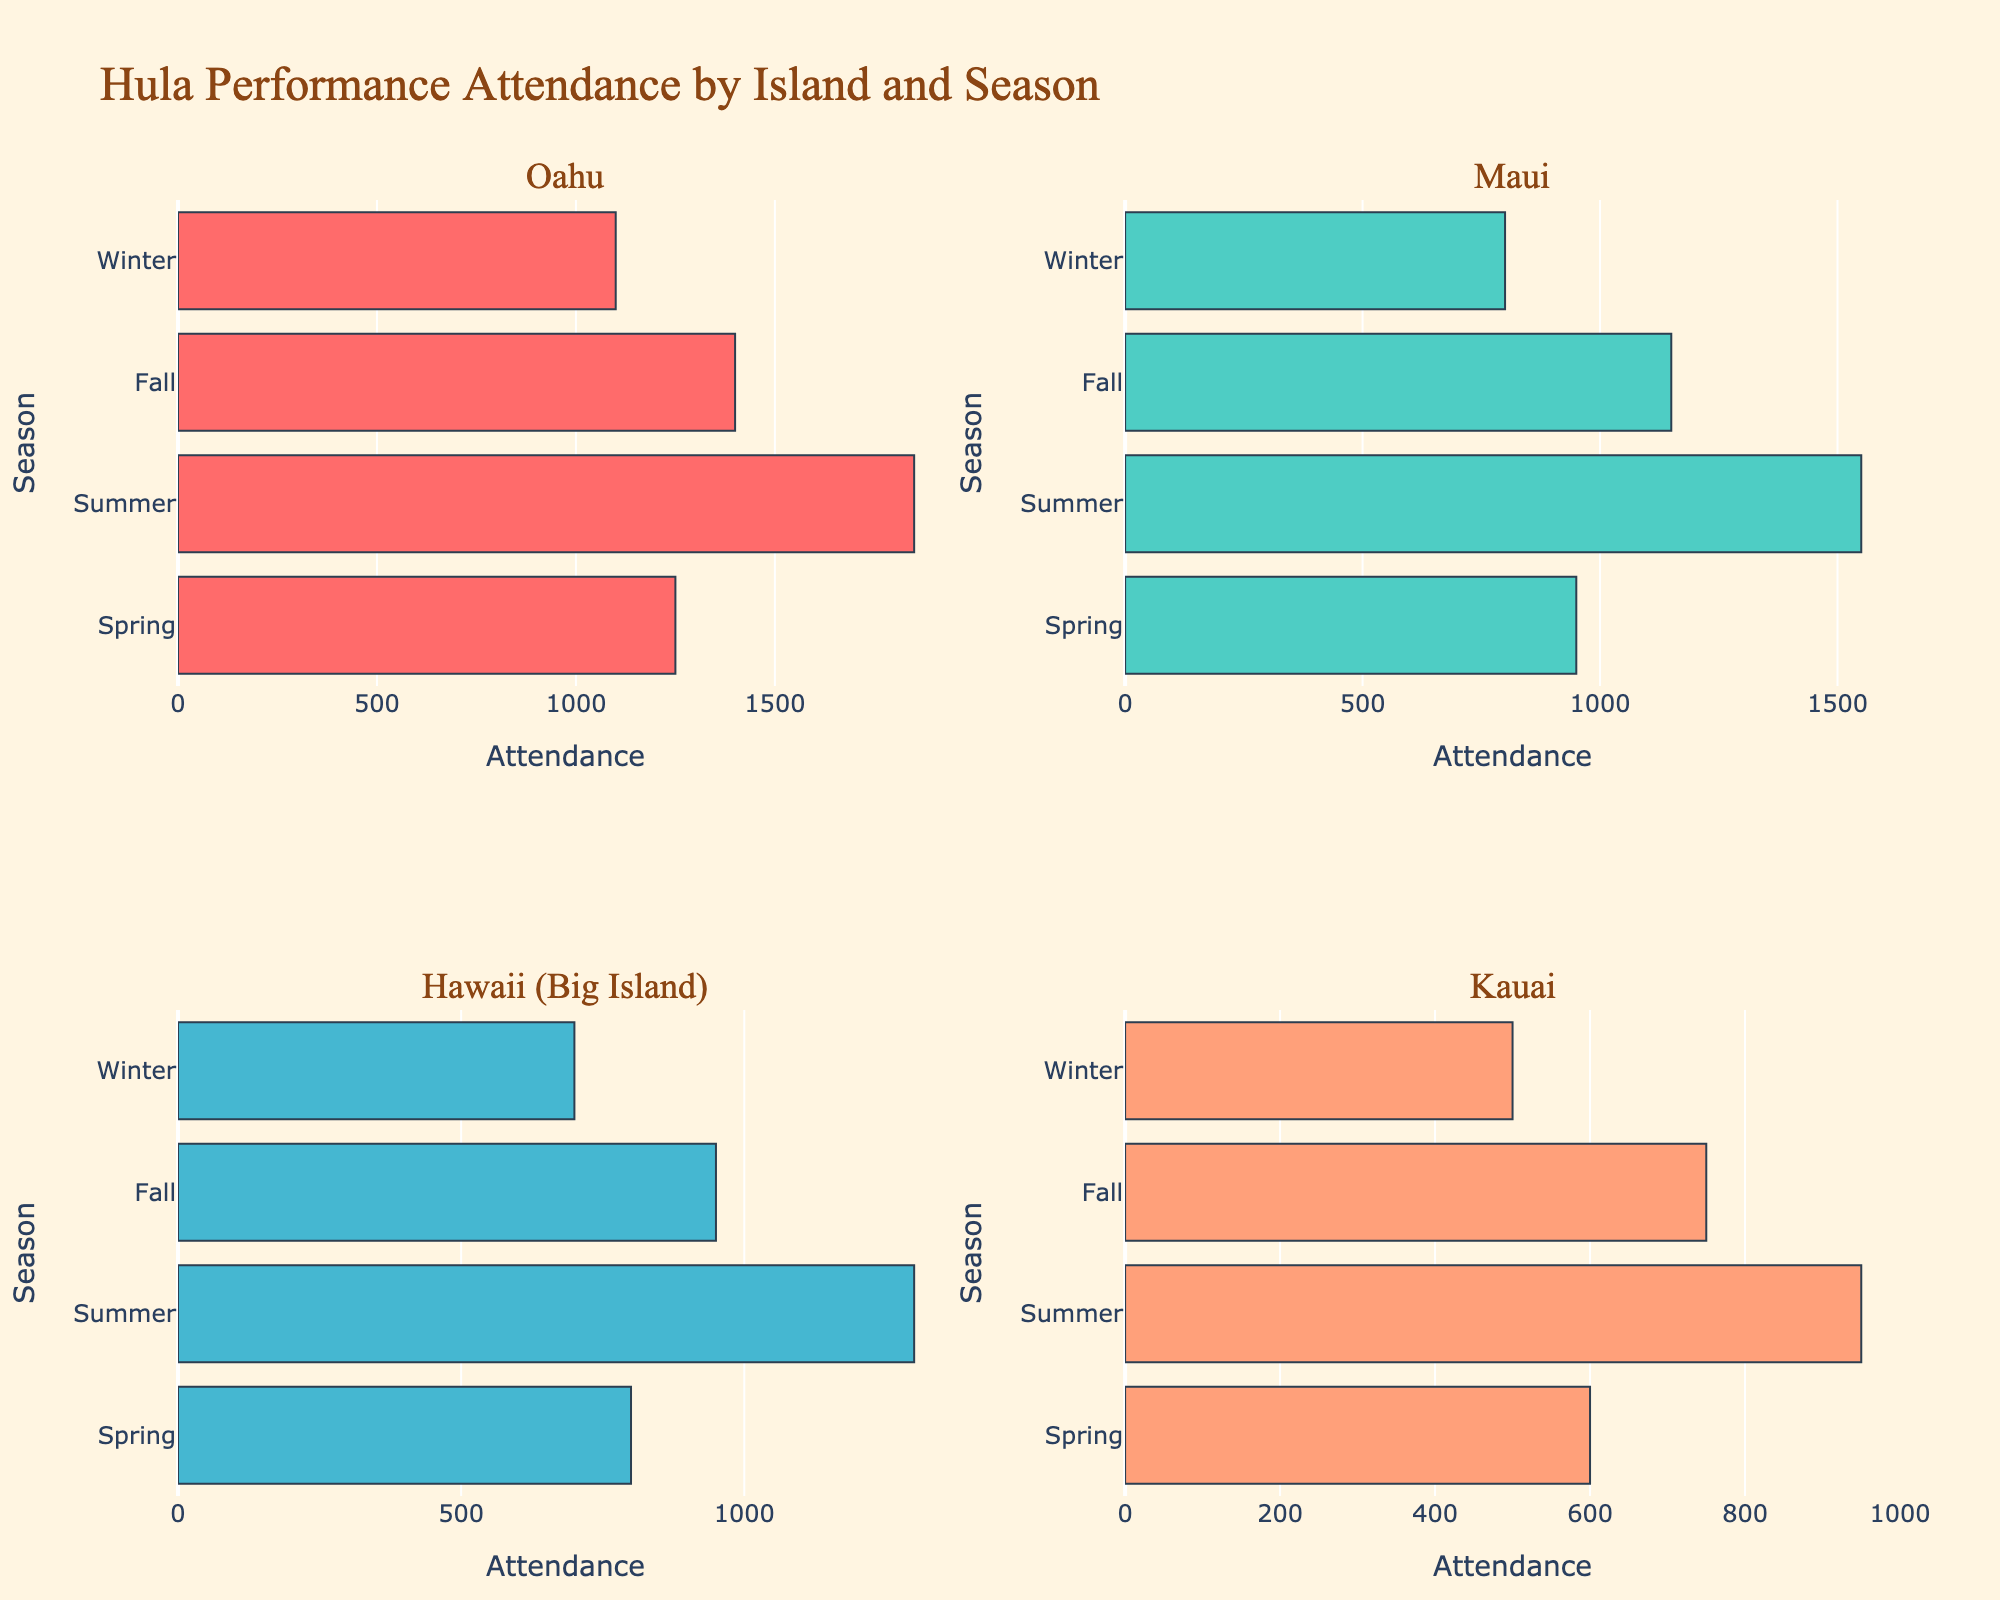What's the attendance for traditional hula performances on Oahu during the summer? Locate the bar corresponding to Oahu and the summer season. The attendance value shown is 1850.
Answer: 1850 Which island has the lowest attendance in the winter? Compare the attendance bars for the winter season across all islands. Kauai has the lowest attendance with 500.
Answer: Kauai What's the total attendance for hula performances on Maui throughout the year? Sum the attendance values for all four seasons on Maui: 950 (Spring) + 1550 (Summer) + 1150 (Fall) + 800 (Winter) = 4450.
Answer: 4450 How does the attendance in the fall compare between Oahu and Hawaii (Big Island)? Compare the fall season attendance bars for Oahu and Hawaii (Big Island). Oahu has 1400 while Hawaii (Big Island) has 950. Oahu’s fall attendance is higher.
Answer: Oahu is higher What is the average attendance in the spring across all islands? Sum the spring attendance values for all islands and divide by the number of islands: (1250 + 950 + 800 + 600) / 4 = 3600 / 4 = 900.
Answer: 900 Which season has the highest attendance on Kauai? Examine the attendance bars for all seasons on Kauai. The summer season has the highest attendance with 950.
Answer: Summer Is the attendance in the winter higher on Oahu or Maui? Compare the winter season attendance bars for Oahu and Maui. Oahu has 1100 while Maui has 800. Oahu’s winter attendance is higher.
Answer: Oahu is higher What's the combined attendance for traditional hula performances in the summer on all islands? Sum the summer attendance values across all islands: 1850 (Oahu) + 1550 (Maui) + 1300 (Hawaii) + 950 (Kauai) = 5650.
Answer: 5650 